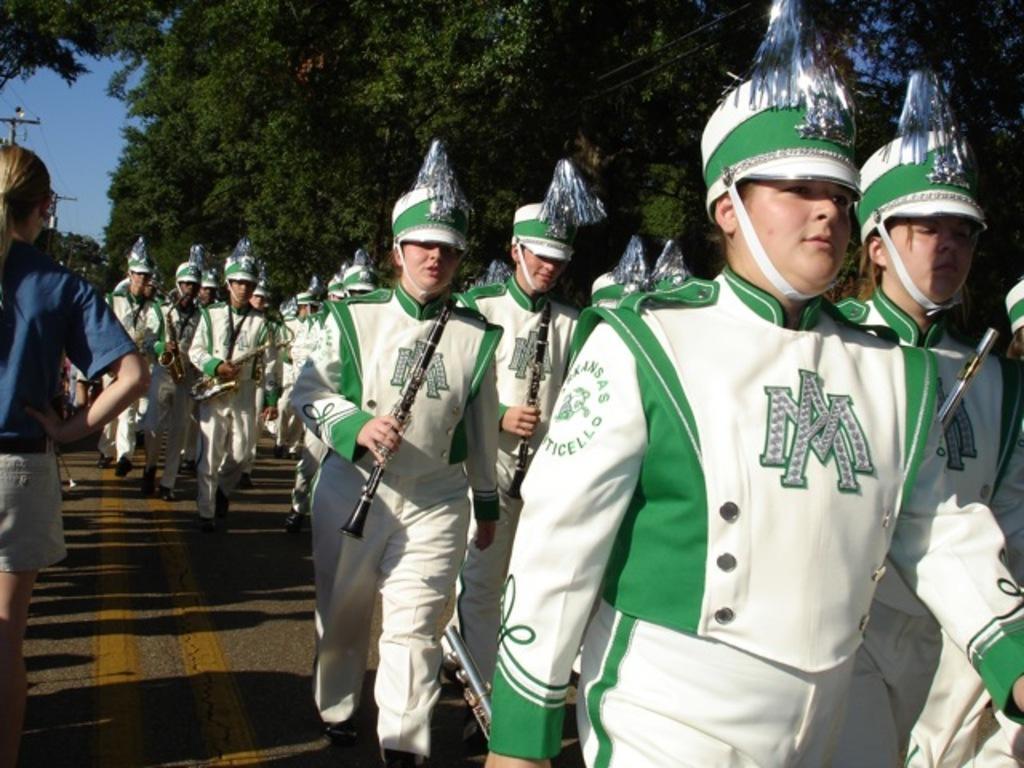Can you describe this image briefly? In this image, I can see a group of people with fancy dresses are walking on the road and holding the musical instruments. On the left side of the image, I can see a person standing and there is a current pole. In the background, there are trees and the sky. 